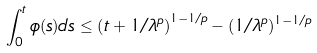<formula> <loc_0><loc_0><loc_500><loc_500>\int _ { 0 } ^ { t } \phi ( s ) d s \leq \left ( t + 1 / \lambda ^ { p } \right ) ^ { 1 - 1 / p } - ( 1 / \lambda ^ { p } ) ^ { 1 - 1 / p }</formula> 